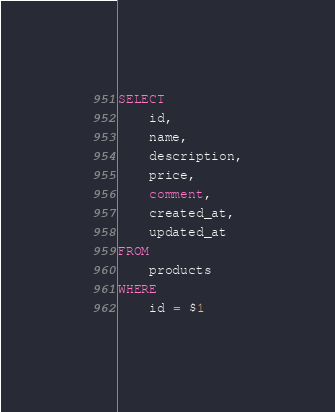<code> <loc_0><loc_0><loc_500><loc_500><_SQL_>SELECT
    id,
    name,
    description,
    price,
    comment,
    created_at,
    updated_at
FROM
    products
WHERE
    id = $1
</code> 